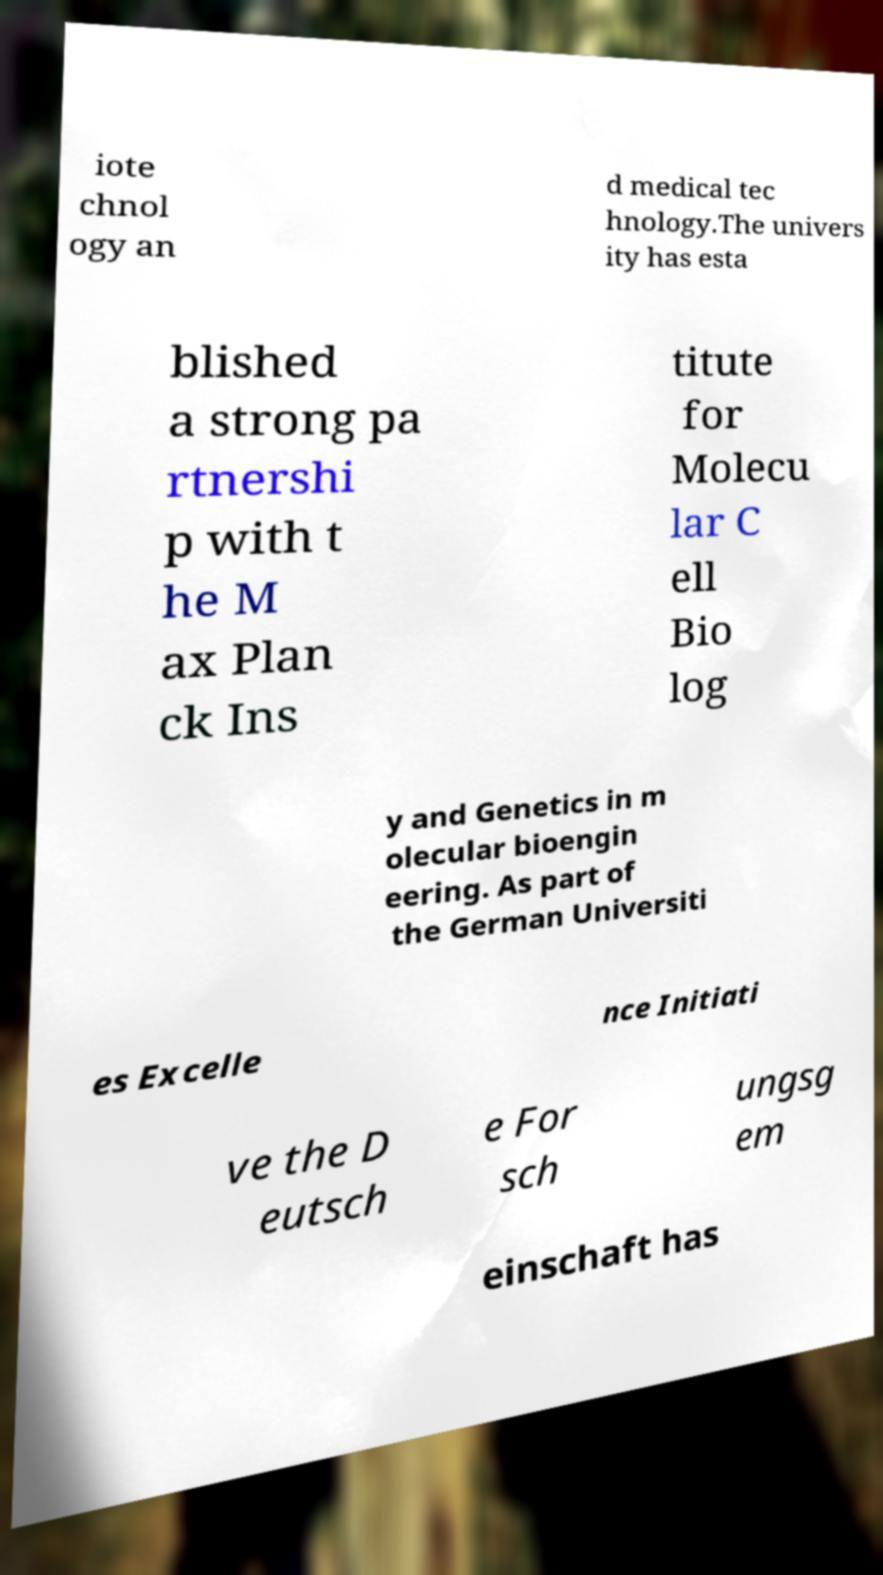Can you accurately transcribe the text from the provided image for me? iote chnol ogy an d medical tec hnology.The univers ity has esta blished a strong pa rtnershi p with t he M ax Plan ck Ins titute for Molecu lar C ell Bio log y and Genetics in m olecular bioengin eering. As part of the German Universiti es Excelle nce Initiati ve the D eutsch e For sch ungsg em einschaft has 